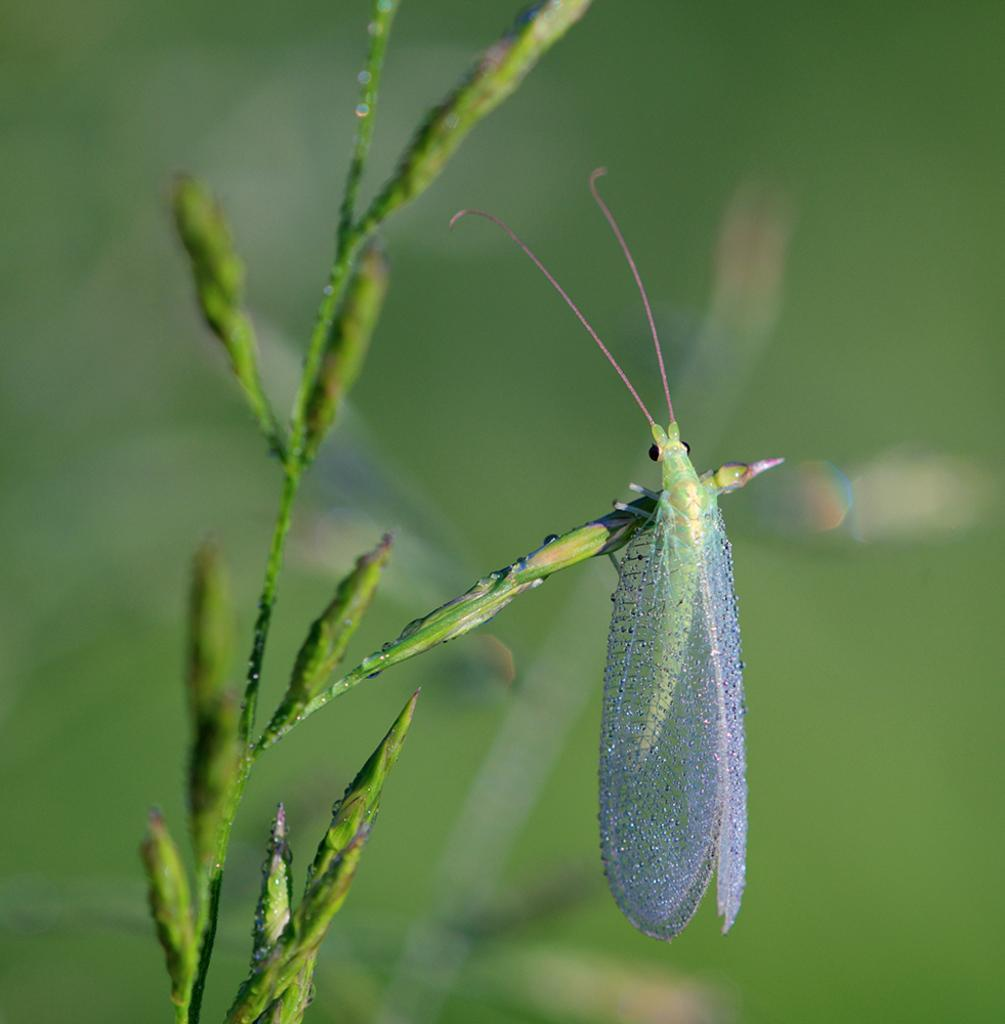What is the main subject of the picture? The main subject of the picture is a plant. Can you describe any living organisms on the plant? Yes, there is a green insect with wings and antennas on the plant. Are there any other plants visible in the image? Yes, there are many plants visible behind the main plant, but they are not clearly visible. What type of wine is being served in the image? There is no wine present in the image; it features a plant with an insect on it. Is there a truck visible in the image? No, there is no truck present in the image. 